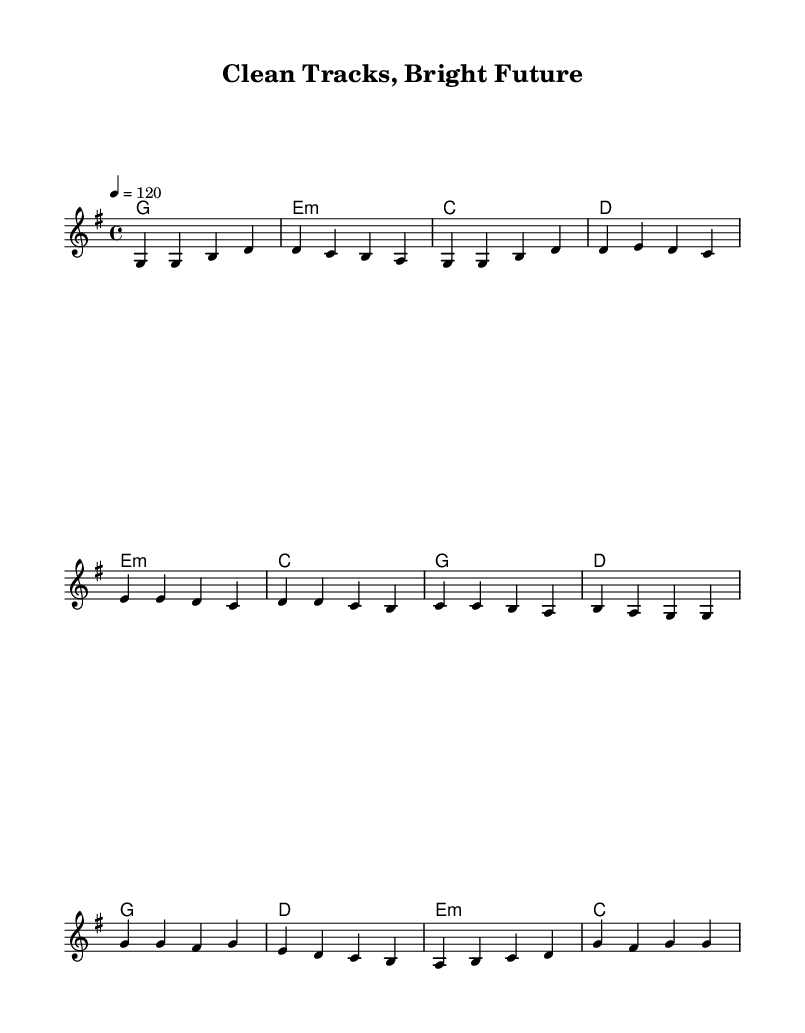What is the key signature of this music? The key signature is G major, which includes one sharp (F#). This is identified by looking at the key signature symbol at the beginning of the staff.
Answer: G major What is the time signature of the piece? The time signature is 4/4, denoted at the beginning of the music. It indicates that there are four beats per measure and the quarter note gets one beat.
Answer: 4/4 What is the tempo marking for the music? The tempo marking is 120 beats per minute (bpm). This is specified in the tempo section of the score, indicating the speed at which the piece should be played.
Answer: 120 How many measures are in the chorus section? The chorus section consists of four measures. By counting the number of measure lines in the chorus part of the score, you can see there are four distinct measures.
Answer: 4 Which chord is used in the first measure of the verse? The first chord in the verse is G major. This can be identified from the chord symbols written above the melody in the score.
Answer: G What is the highest note in the melody? The highest note in the melody is B. This can be determined by scanning through the notes in the melody line and identifying the highest pitch.
Answer: B What type of musical genre does this piece represent? This piece represents the Pop genre, which is characterized by its catchy melodies and themes of community pride and respect for shared environments, as indicated by the title and content.
Answer: Pop 